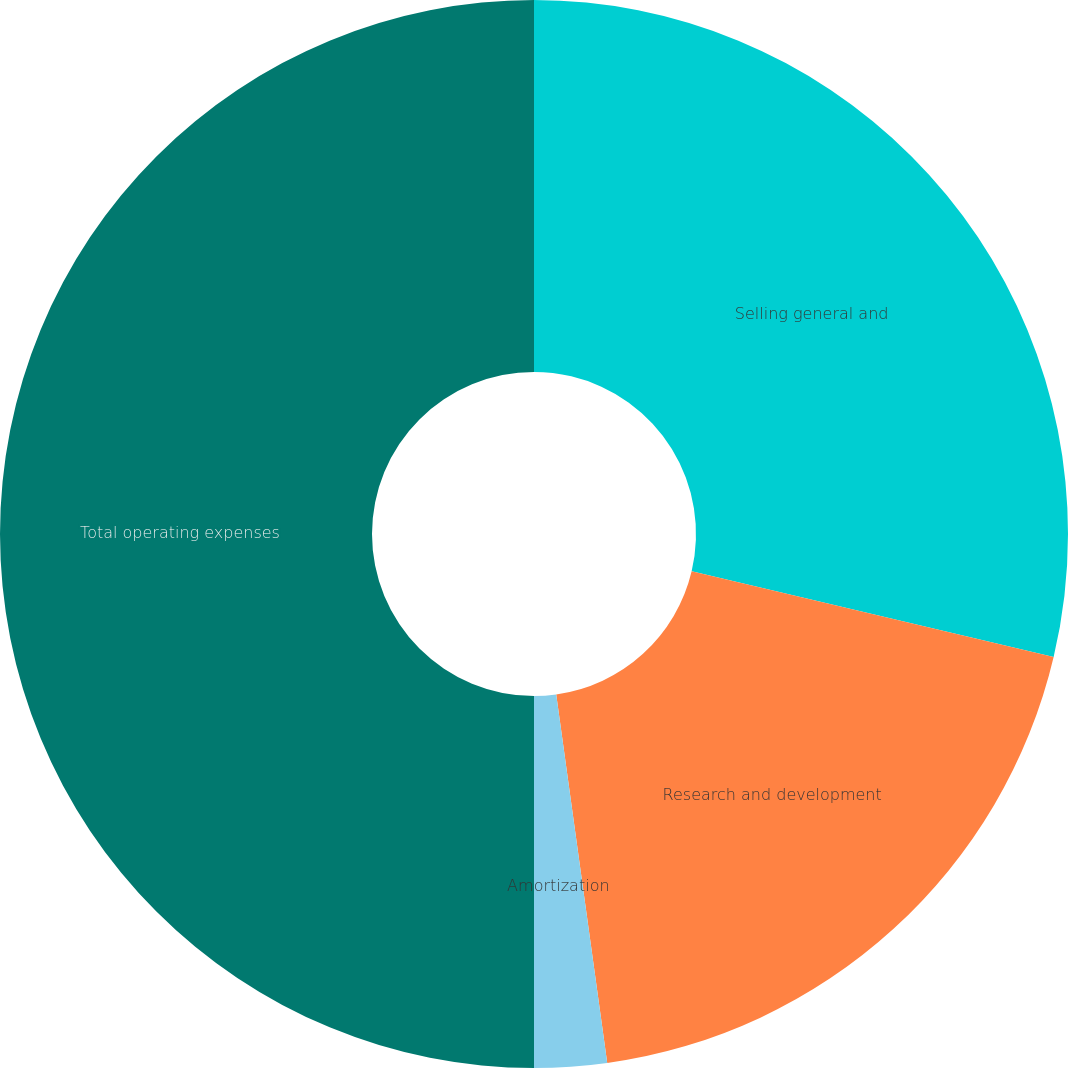Convert chart. <chart><loc_0><loc_0><loc_500><loc_500><pie_chart><fcel>Selling general and<fcel>Research and development<fcel>Amortization<fcel>Total operating expenses<nl><fcel>28.7%<fcel>19.11%<fcel>2.19%<fcel>50.0%<nl></chart> 